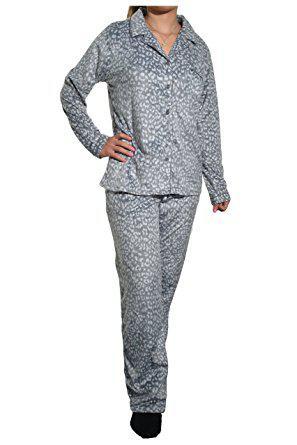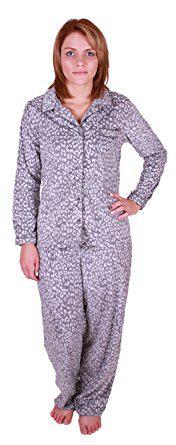The first image is the image on the left, the second image is the image on the right. For the images shown, is this caption "Both models are wearing the same design of pajamas." true? Answer yes or no. Yes. The first image is the image on the left, the second image is the image on the right. Examine the images to the left and right. Is the description "Each model wears printed pajamas, and each pajama outfit includes a button-up top with a shirt collar." accurate? Answer yes or no. Yes. 